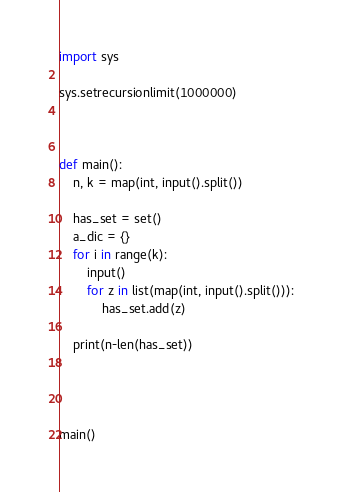Convert code to text. <code><loc_0><loc_0><loc_500><loc_500><_Python_>import sys

sys.setrecursionlimit(1000000)



def main():
    n, k = map(int, input().split())

    has_set = set()
    a_dic = {}
    for i in range(k):
        input()
        for z in list(map(int, input().split())):
            has_set.add(z)

    print(n-len(has_set))




main()
</code> 